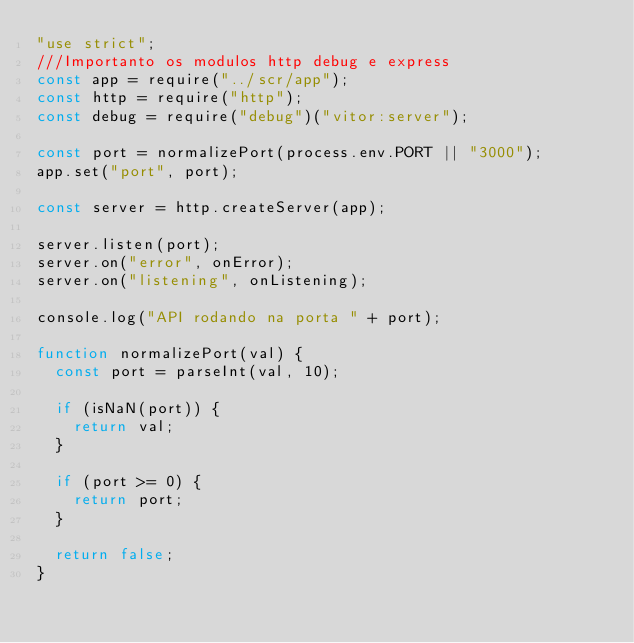Convert code to text. <code><loc_0><loc_0><loc_500><loc_500><_JavaScript_>"use strict";
///Importanto os modulos http debug e express
const app = require("../scr/app");
const http = require("http");
const debug = require("debug")("vitor:server");

const port = normalizePort(process.env.PORT || "3000");
app.set("port", port);

const server = http.createServer(app);

server.listen(port);
server.on("error", onError);
server.on("listening", onListening);

console.log("API rodando na porta " + port);

function normalizePort(val) {
  const port = parseInt(val, 10);

  if (isNaN(port)) {
    return val;
  }

  if (port >= 0) {
    return port;
  }

  return false;
}
</code> 